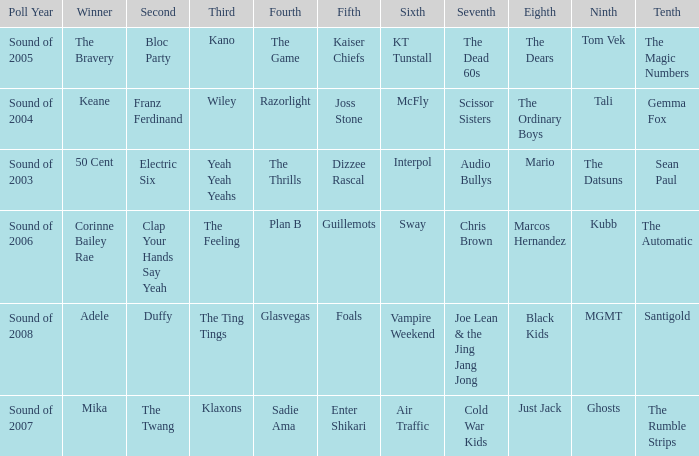When dizzee rascal is 5th, who was the winner? 50 Cent. Could you parse the entire table as a dict? {'header': ['Poll Year', 'Winner', 'Second', 'Third', 'Fourth', 'Fifth', 'Sixth', 'Seventh', 'Eighth', 'Ninth', 'Tenth'], 'rows': [['Sound of 2005', 'The Bravery', 'Bloc Party', 'Kano', 'The Game', 'Kaiser Chiefs', 'KT Tunstall', 'The Dead 60s', 'The Dears', 'Tom Vek', 'The Magic Numbers'], ['Sound of 2004', 'Keane', 'Franz Ferdinand', 'Wiley', 'Razorlight', 'Joss Stone', 'McFly', 'Scissor Sisters', 'The Ordinary Boys', 'Tali', 'Gemma Fox'], ['Sound of 2003', '50 Cent', 'Electric Six', 'Yeah Yeah Yeahs', 'The Thrills', 'Dizzee Rascal', 'Interpol', 'Audio Bullys', 'Mario', 'The Datsuns', 'Sean Paul'], ['Sound of 2006', 'Corinne Bailey Rae', 'Clap Your Hands Say Yeah', 'The Feeling', 'Plan B', 'Guillemots', 'Sway', 'Chris Brown', 'Marcos Hernandez', 'Kubb', 'The Automatic'], ['Sound of 2008', 'Adele', 'Duffy', 'The Ting Tings', 'Glasvegas', 'Foals', 'Vampire Weekend', 'Joe Lean & the Jing Jang Jong', 'Black Kids', 'MGMT', 'Santigold'], ['Sound of 2007', 'Mika', 'The Twang', 'Klaxons', 'Sadie Ama', 'Enter Shikari', 'Air Traffic', 'Cold War Kids', 'Just Jack', 'Ghosts', 'The Rumble Strips']]} 